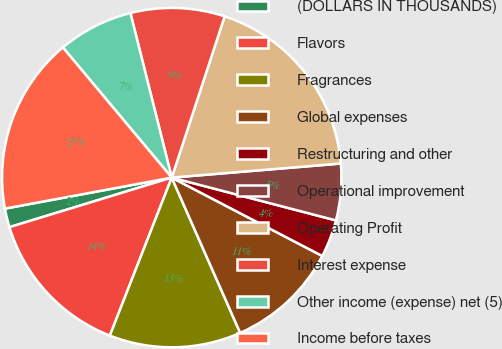Convert chart to OTSL. <chart><loc_0><loc_0><loc_500><loc_500><pie_chart><fcel>(DOLLARS IN THOUSANDS)<fcel>Flavors<fcel>Fragrances<fcel>Global expenses<fcel>Restructuring and other<fcel>Operational improvement<fcel>Operating Profit<fcel>Interest expense<fcel>Other income (expense) net (5)<fcel>Income before taxes<nl><fcel>1.79%<fcel>14.34%<fcel>12.55%<fcel>10.75%<fcel>3.58%<fcel>5.38%<fcel>18.63%<fcel>8.96%<fcel>7.17%<fcel>16.84%<nl></chart> 